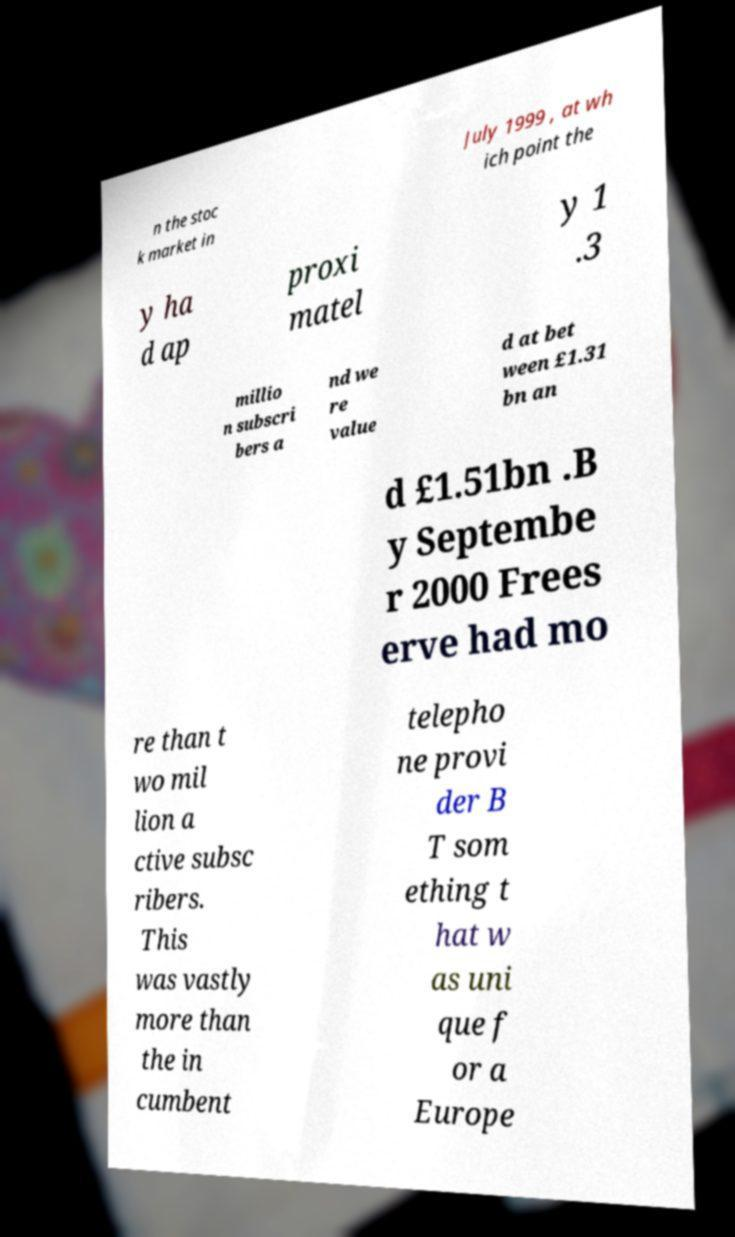Please identify and transcribe the text found in this image. n the stoc k market in July 1999 , at wh ich point the y ha d ap proxi matel y 1 .3 millio n subscri bers a nd we re value d at bet ween £1.31 bn an d £1.51bn .B y Septembe r 2000 Frees erve had mo re than t wo mil lion a ctive subsc ribers. This was vastly more than the in cumbent telepho ne provi der B T som ething t hat w as uni que f or a Europe 